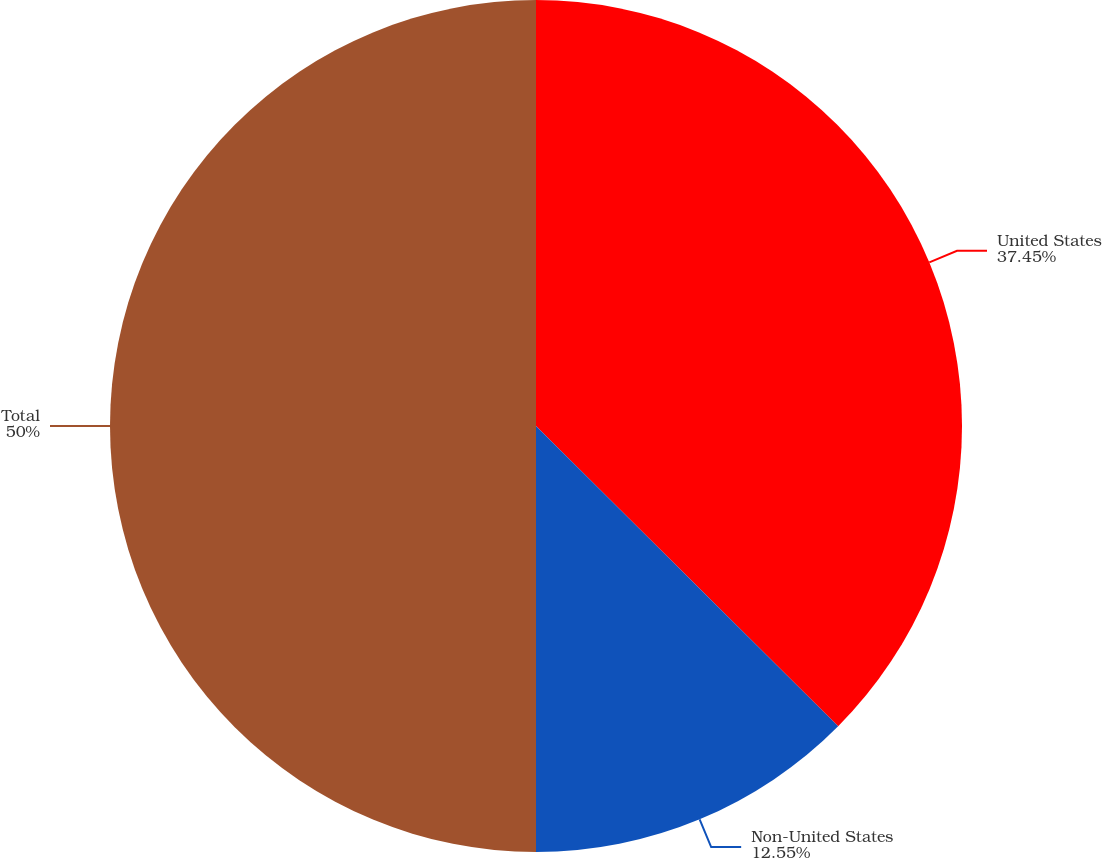Convert chart to OTSL. <chart><loc_0><loc_0><loc_500><loc_500><pie_chart><fcel>United States<fcel>Non-United States<fcel>Total<nl><fcel>37.45%<fcel>12.55%<fcel>50.0%<nl></chart> 